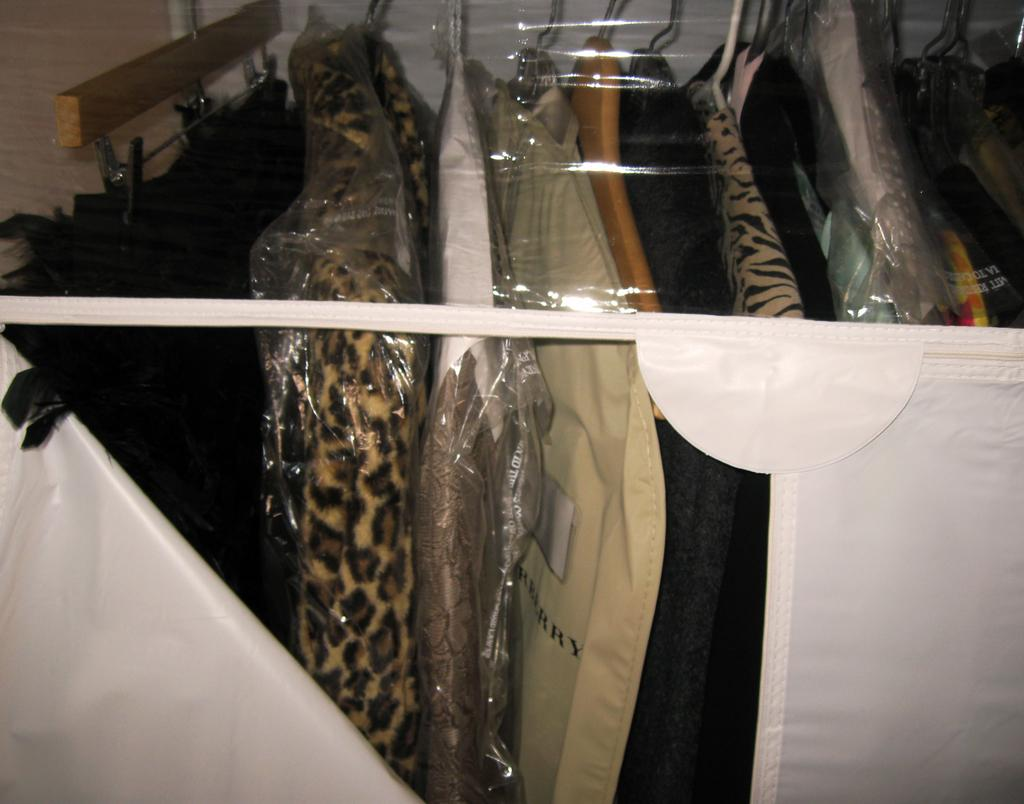What type of clothing can be seen in the image? There are suits in the image. Where are the suits located? The suits are hanging in a cupboard. What type of dinosaurs can be seen in the image? There are no dinosaurs present in the image; it features suits hanging in a cupboard. What does the person need to do with the suits in the image? The image does not indicate any specific action or need related to the suits. 